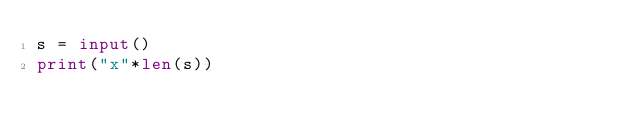<code> <loc_0><loc_0><loc_500><loc_500><_Python_>s = input()
print("x"*len(s))</code> 